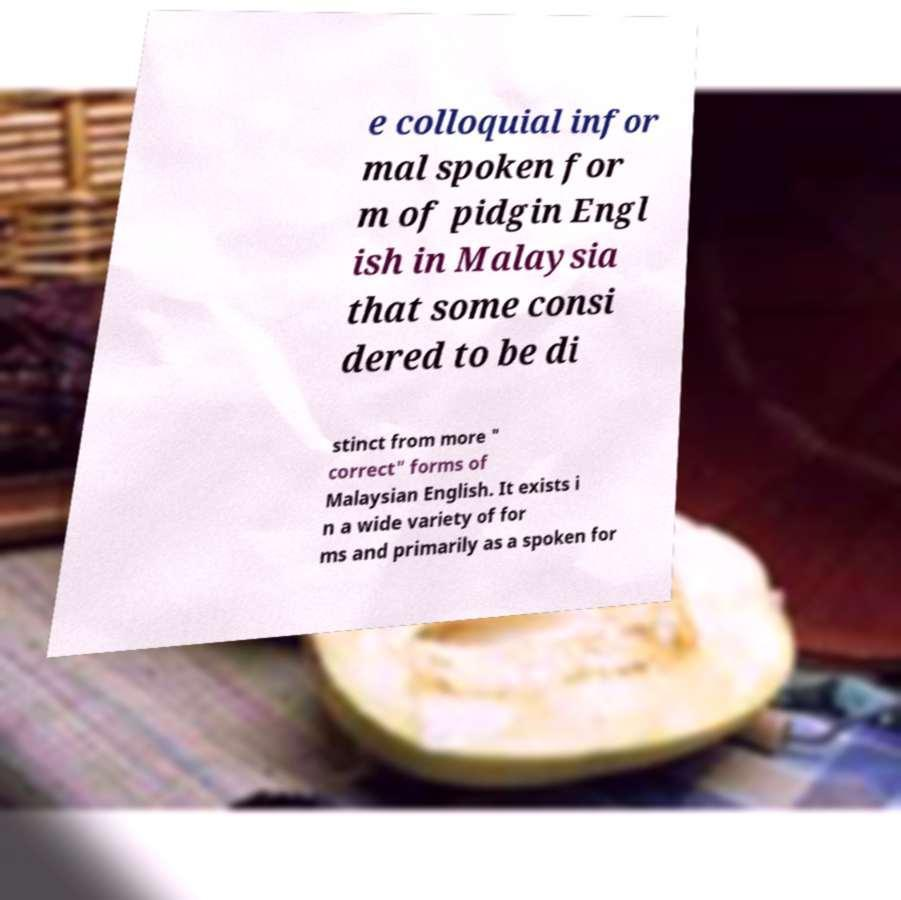What messages or text are displayed in this image? I need them in a readable, typed format. e colloquial infor mal spoken for m of pidgin Engl ish in Malaysia that some consi dered to be di stinct from more " correct" forms of Malaysian English. It exists i n a wide variety of for ms and primarily as a spoken for 